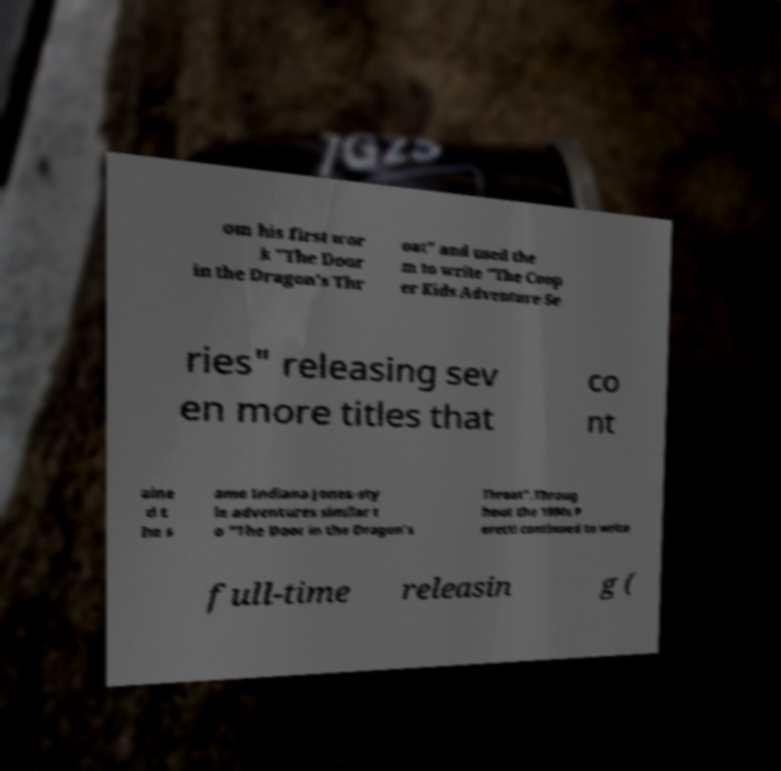Can you accurately transcribe the text from the provided image for me? om his first wor k "The Door in the Dragon's Thr oat" and used the m to write "The Coop er Kids Adventure Se ries" releasing sev en more titles that co nt aine d t he s ame Indiana Jones-sty le adventures similar t o "The Door in the Dragon's Throat".Throug hout the 1990s P eretti continued to write full-time releasin g ( 